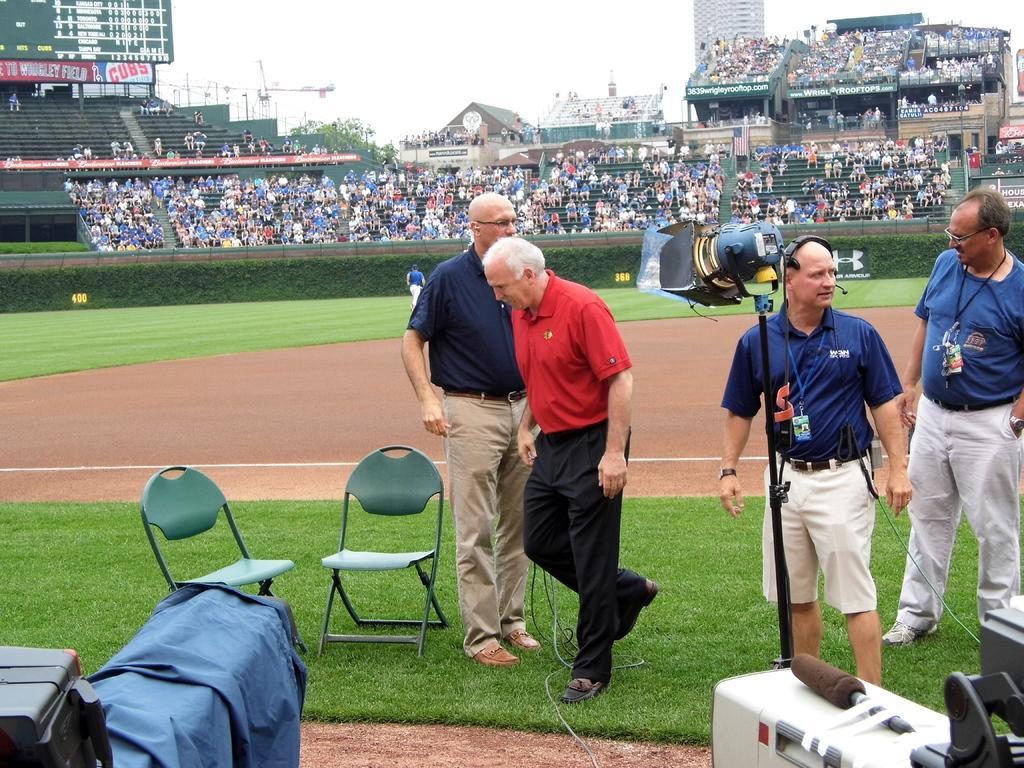In one or two sentences, can you explain what this image depicts? In this image we can see some persons standing in the foreground of the image two persons wearing blue color T-shirts also wearing Identity cards and a person put his headphones there is camera and chairs which are of green color and in the background of the image there are some spectators, buildings, tree and clear sky. 